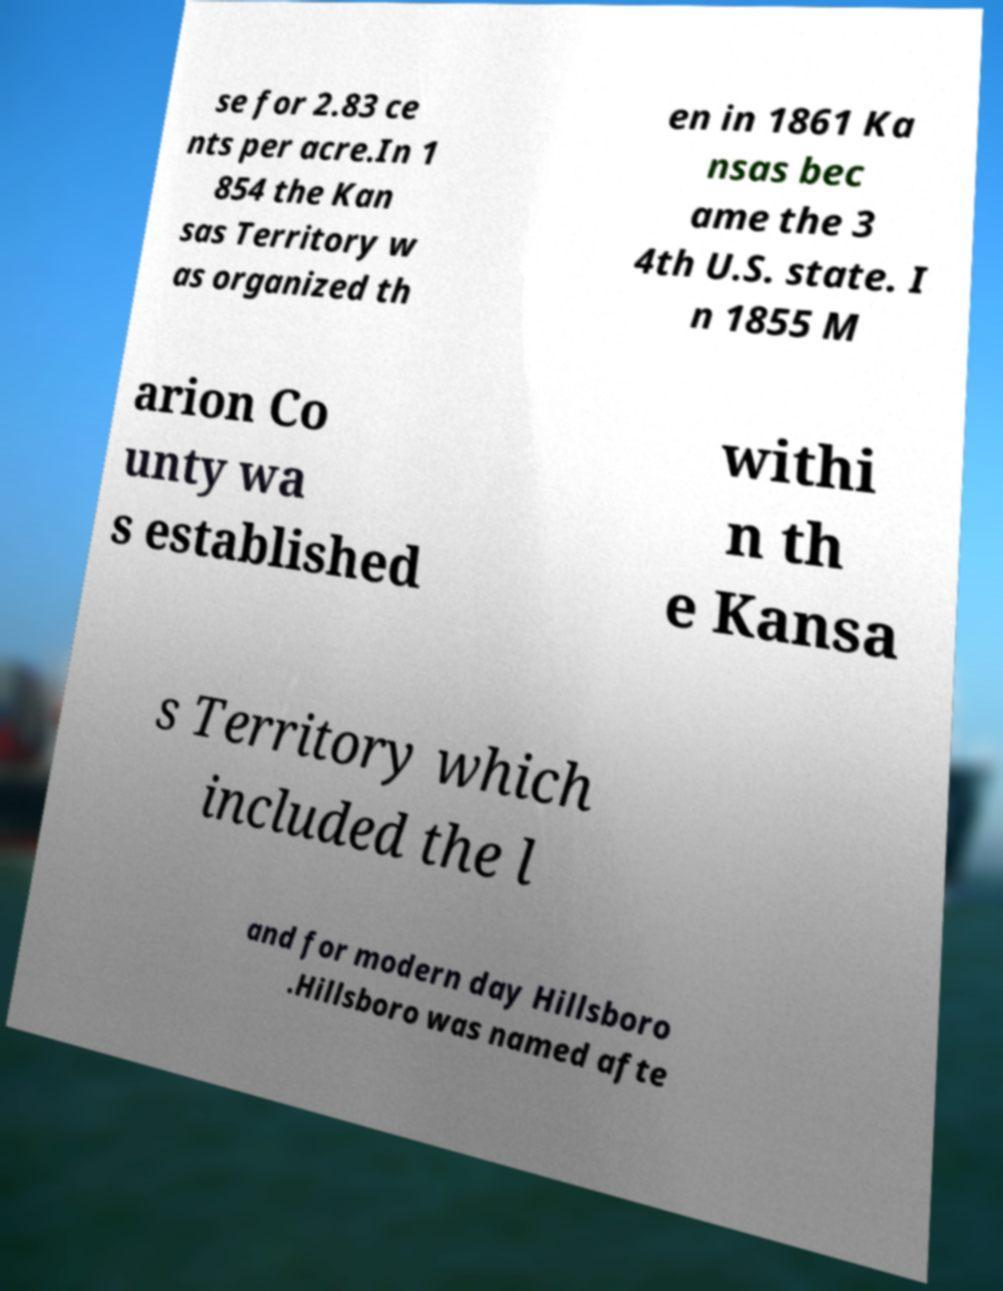Can you accurately transcribe the text from the provided image for me? se for 2.83 ce nts per acre.In 1 854 the Kan sas Territory w as organized th en in 1861 Ka nsas bec ame the 3 4th U.S. state. I n 1855 M arion Co unty wa s established withi n th e Kansa s Territory which included the l and for modern day Hillsboro .Hillsboro was named afte 